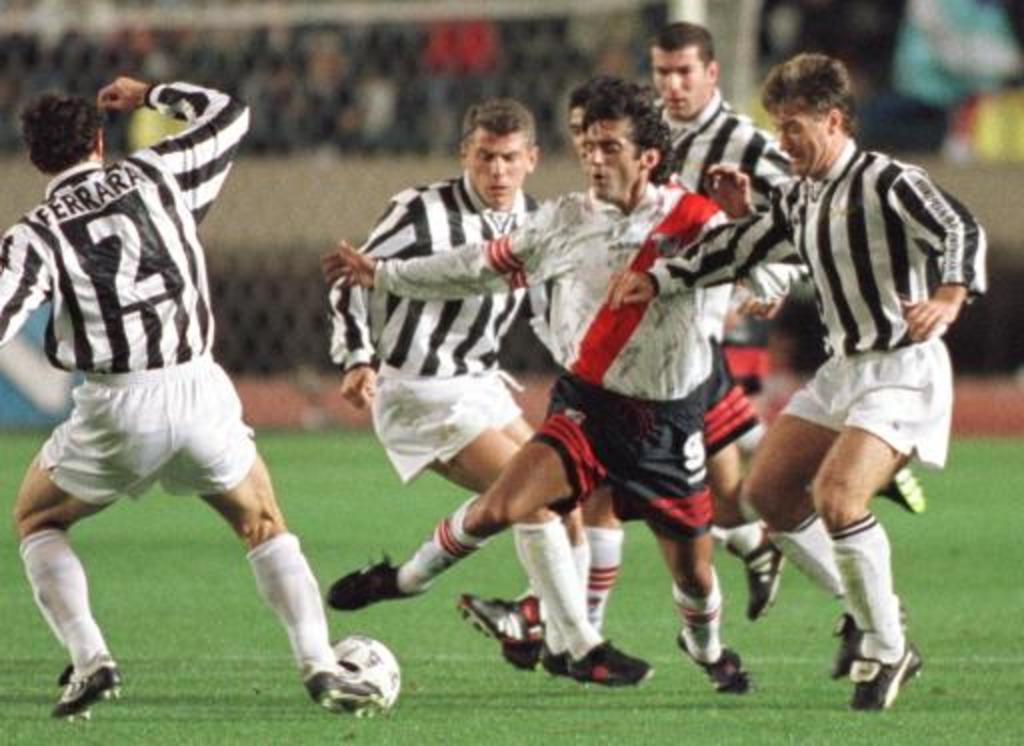Can you describe this image briefly? In this image i can see group of people playing foot ball,at the ground i can see the grass,at the background i can see the railing. 